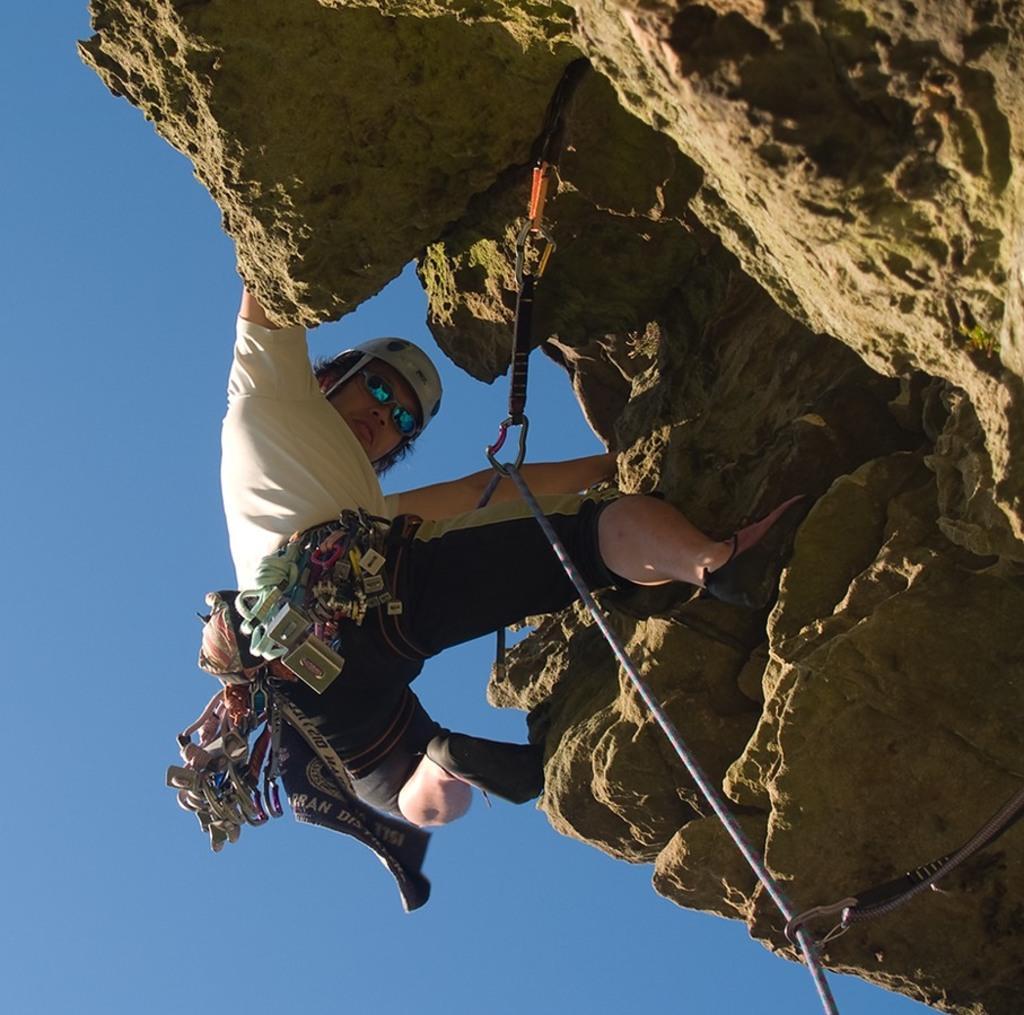Please provide a concise description of this image. This image consists of a person climbing the mountain. And tied with a rope. On the right, we can see a rock. At the top, there is sky. 